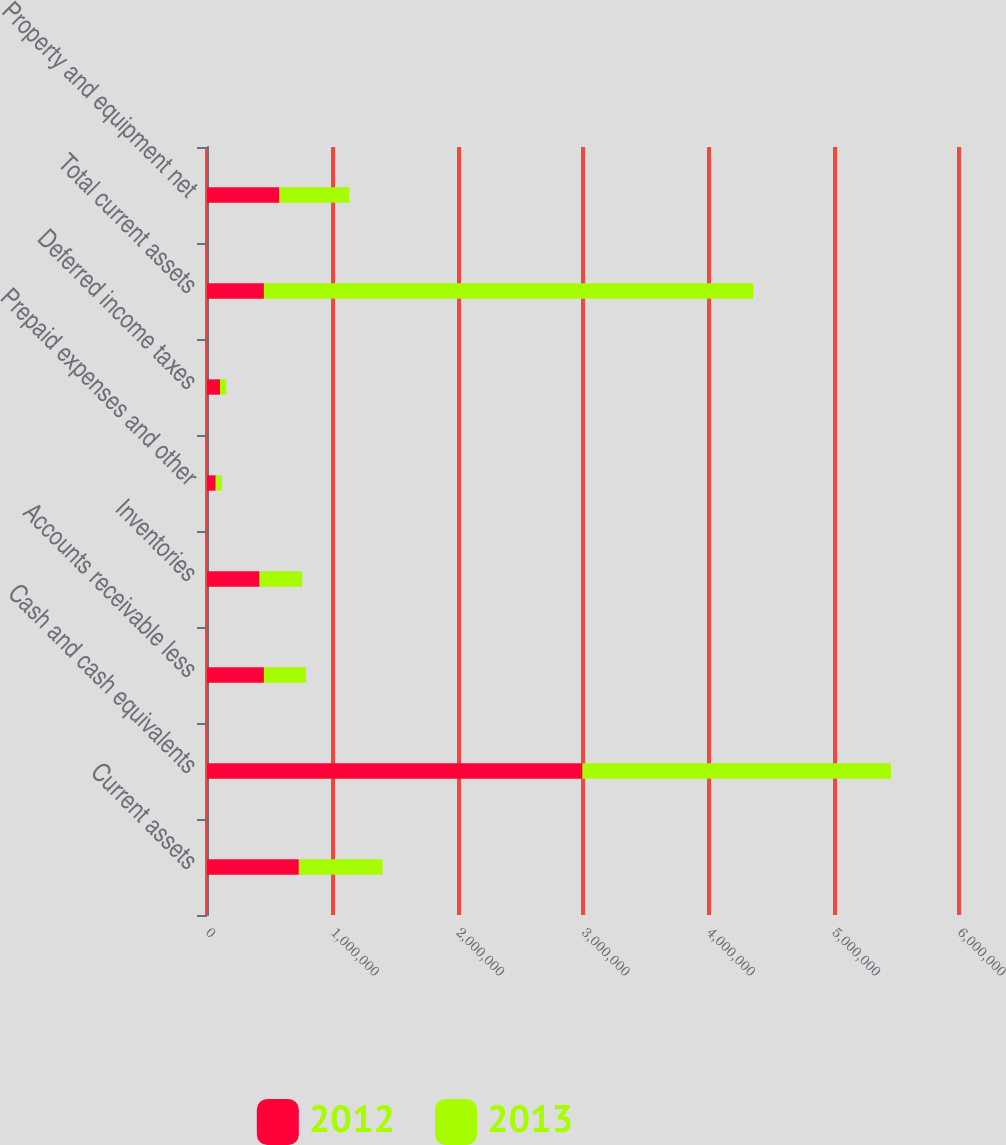Convert chart to OTSL. <chart><loc_0><loc_0><loc_500><loc_500><stacked_bar_chart><ecel><fcel>Current assets<fcel>Cash and cash equivalents<fcel>Accounts receivable less<fcel>Inventories<fcel>Prepaid expenses and other<fcel>Deferred income taxes<fcel>Total current assets<fcel>Property and equipment net<nl><fcel>2012<fcel>732786<fcel>2.9951e+06<fcel>454252<fcel>419686<fcel>69701<fcel>103736<fcel>454252<fcel>576144<nl><fcel>2013<fcel>667876<fcel>2.4617e+06<fcel>336143<fcel>340297<fcel>49411<fcel>49931<fcel>3.90536e+06<fcel>560072<nl></chart> 